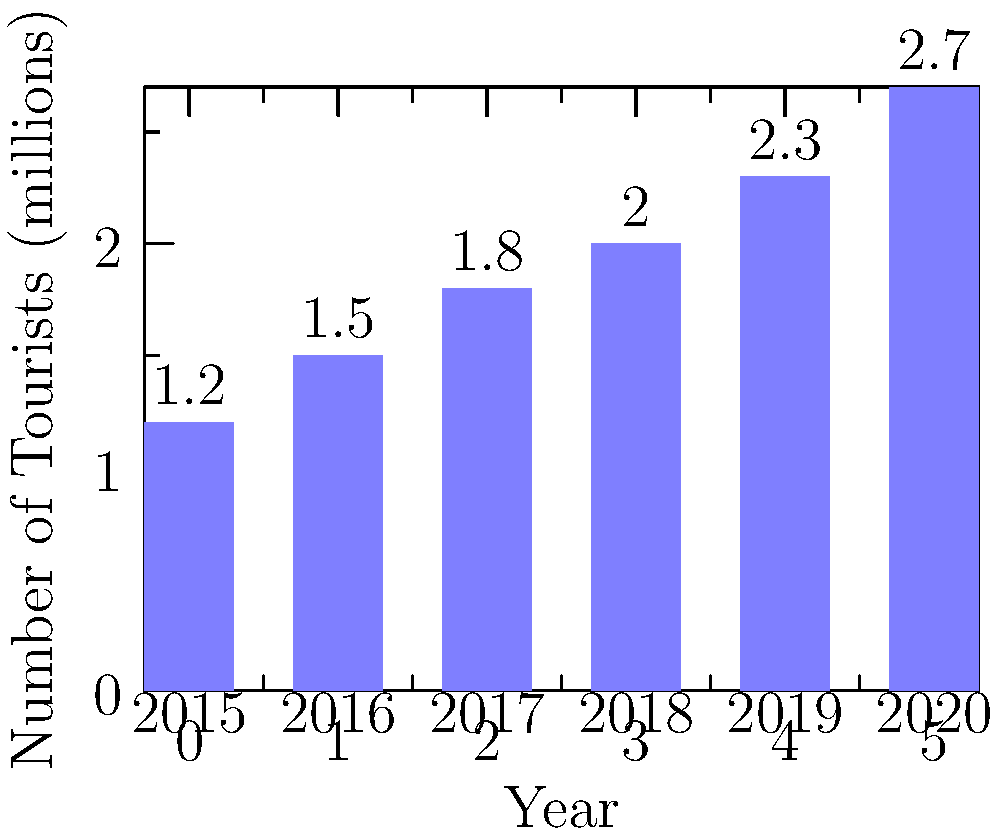The bar chart shows the number of tourists visiting the Bahamas from 2015 to 2020. Calculate the average annual growth rate of tourism during this period. To calculate the average annual growth rate:

1. Calculate total growth:
   Final value (2020): 2.7 million
   Initial value (2015): 1.2 million
   Total growth = (2.7 - 1.2) / 1.2 = 1.25 or 125%

2. Determine the number of years: 2020 - 2015 = 5 years

3. Use the formula for average annual growth rate:
   $$(1 + r)^n = \frac{\text{Final Value}}{\text{Initial Value}}$$
   Where $r$ is the growth rate and $n$ is the number of years

4. Plug in the values:
   $(1 + r)^5 = \frac{2.7}{1.2} = 2.25$

5. Solve for $r$:
   $1 + r = (2.25)^{\frac{1}{5}} = 1.1762$
   $r = 1.1762 - 1 = 0.1762$

6. Convert to percentage:
   0.1762 * 100 = 17.62%

The average annual growth rate is approximately 17.62%.
Answer: 17.62% 